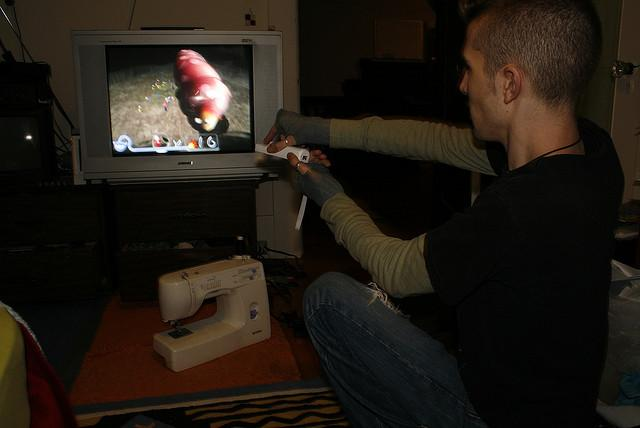The item on the floor looks like what? Please explain your reasoning. sewing machine. It's a portable machine that sews fabrics. 